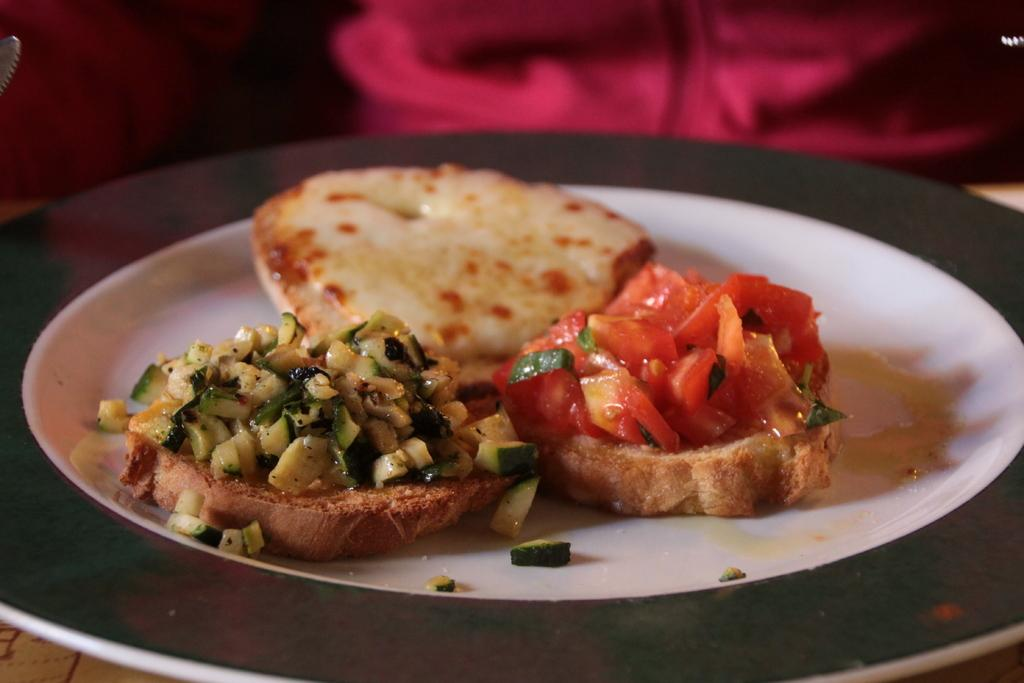What is on the plate that is visible in the image? There is a food item on a plate in the image. Where is the plate located in the image? The plate is placed on a table in the image. Can you describe the background of the image? The background of the image is blurred. What type of instrument is the passenger playing in the image? There is no passenger or instrument present in the image. How many ladybugs can be seen on the food item in the image? There are no ladybugs visible on the food item in the image. 